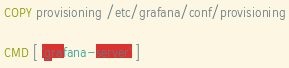Convert code to text. <code><loc_0><loc_0><loc_500><loc_500><_Dockerfile_>COPY provisioning /etc/grafana/conf/provisioning

CMD [ 'grafana-server' ]</code> 